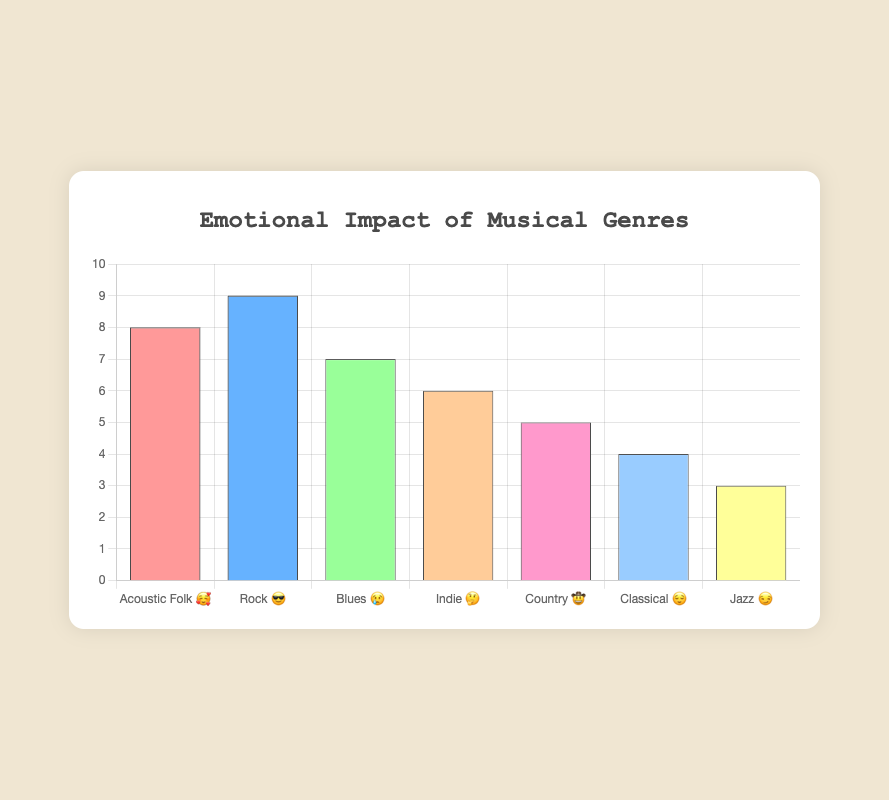What is the title of the chart? The title of the chart is located at the top, centered above the chart, and it reads "Emotional Impact of Musical Genres".
Answer: Emotional Impact of Musical Genres Which genre has the highest listener engagement? Looking at the bar heights which represent listener engagement, the "Rock" genre has the tallest bar with an engagement value of 9.
Answer: Rock Which genre has the lowest listener engagement and what is its emotional impact emoji? Observing the shortest bar in the chart, the genre "Jazz" has the lowest listener engagement with a value of 3. The emotional impact emoji for Jazz is 😏.
Answer: Jazz, 😏 How many genres are represented in the chart? Counting the number of different bars or labels on the x-axis, there are 7 genres shown in the chart.
Answer: 7 What is the combined listener engagement for "Country" and "Indie"? The listener engagement for Country is 5 and for Indie is 6. Adding these values gives 5 + 6 = 11.
Answer: 11 How do "Blues" and "Classical" genres compare in terms of listener engagement? The Blues genre has a listener engagement of 7, while the Classical genre has an engagement of 4. Therefore, Blues has a higher listener engagement than Classical.
Answer: Blues has higher engagement What emotional impact is associated with the genre that has the second-highest listener engagement? The genre with the second-highest listener engagement is "Acoustic Folk" with an engagement value of 8. The emotional impact emoji for Acoustic Folk is 🥰.
Answer: 🥰 What is the average listener engagement across all genres? Summing the listener engagement values (8 + 9 + 7 + 6 + 5 + 4 + 3) gives 42. Dividing by the number of genres (7) gives an average engagement of 42/7 = 6.
Answer: 6 Which genre has a listener engagement value closest to the average engagement? The average listener engagement is 6. The genre with exactly 6 listener engagement is "Indie".
Answer: Indie 